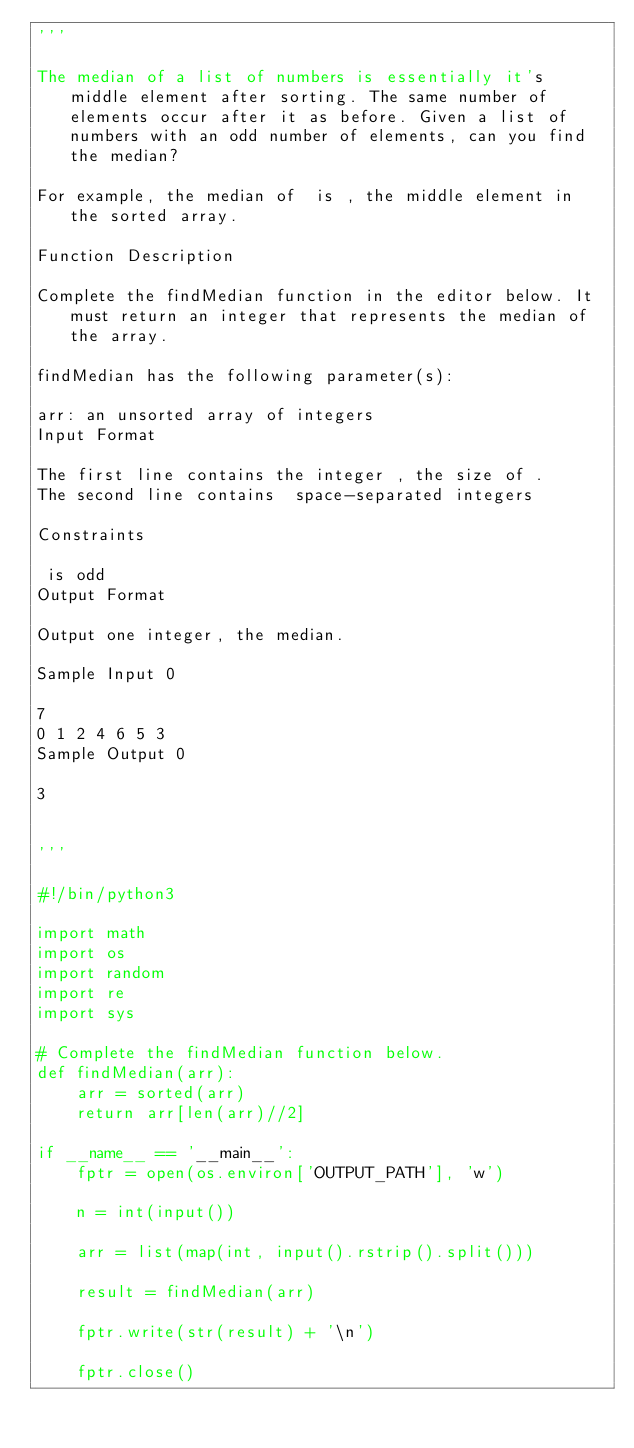<code> <loc_0><loc_0><loc_500><loc_500><_Python_>'''

The median of a list of numbers is essentially it's middle element after sorting. The same number of elements occur after it as before. Given a list of numbers with an odd number of elements, can you find the median?

For example, the median of  is , the middle element in the sorted array.

Function Description

Complete the findMedian function in the editor below. It must return an integer that represents the median of the array.

findMedian has the following parameter(s):

arr: an unsorted array of integers
Input Format

The first line contains the integer , the size of .
The second line contains  space-separated integers 

Constraints

 is odd
Output Format

Output one integer, the median.

Sample Input 0

7
0 1 2 4 6 5 3
Sample Output 0

3


'''

#!/bin/python3

import math
import os
import random
import re
import sys

# Complete the findMedian function below.
def findMedian(arr):
    arr = sorted(arr)
    return arr[len(arr)//2]

if __name__ == '__main__':
    fptr = open(os.environ['OUTPUT_PATH'], 'w')

    n = int(input())

    arr = list(map(int, input().rstrip().split()))

    result = findMedian(arr)

    fptr.write(str(result) + '\n')

    fptr.close()
</code> 